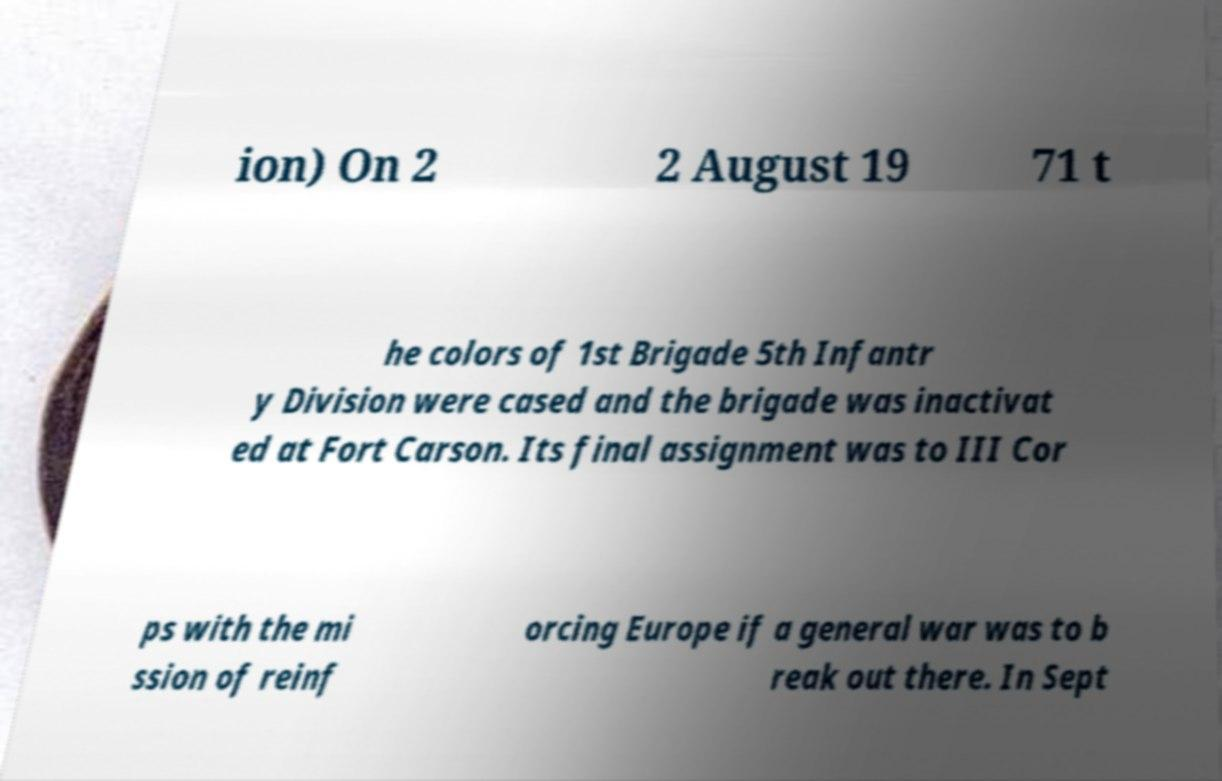For documentation purposes, I need the text within this image transcribed. Could you provide that? ion) On 2 2 August 19 71 t he colors of 1st Brigade 5th Infantr y Division were cased and the brigade was inactivat ed at Fort Carson. Its final assignment was to III Cor ps with the mi ssion of reinf orcing Europe if a general war was to b reak out there. In Sept 